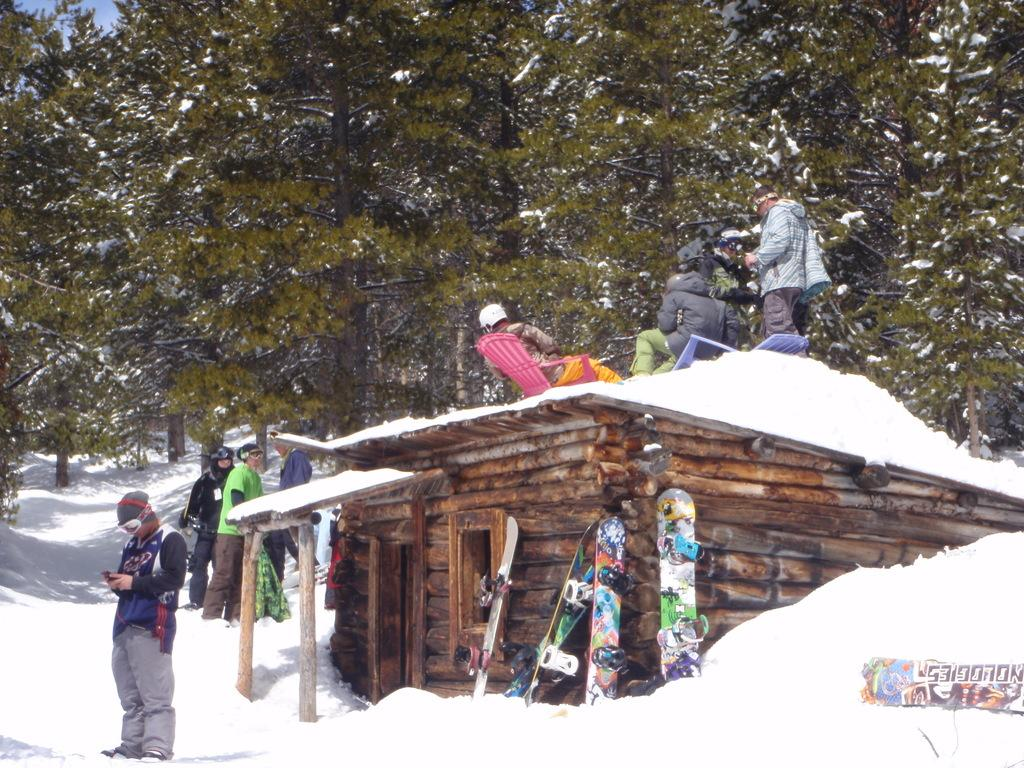What can be seen in the image? There are people standing in the image. What is the ground made of in the image? There is snow at the bottom of the image. What equipment are the people using? Ski boards are visible in the image. Where is the room located in the image? There is a room in the image. What type of vegetation can be seen in the background? There are trees in the background of the image. What type of linen is being washed in the image? There is no linen or washing activity present in the image. What type of spade is being used to dig in the snow? There is no spade present in the image; the people are using ski boards for a different activity. 